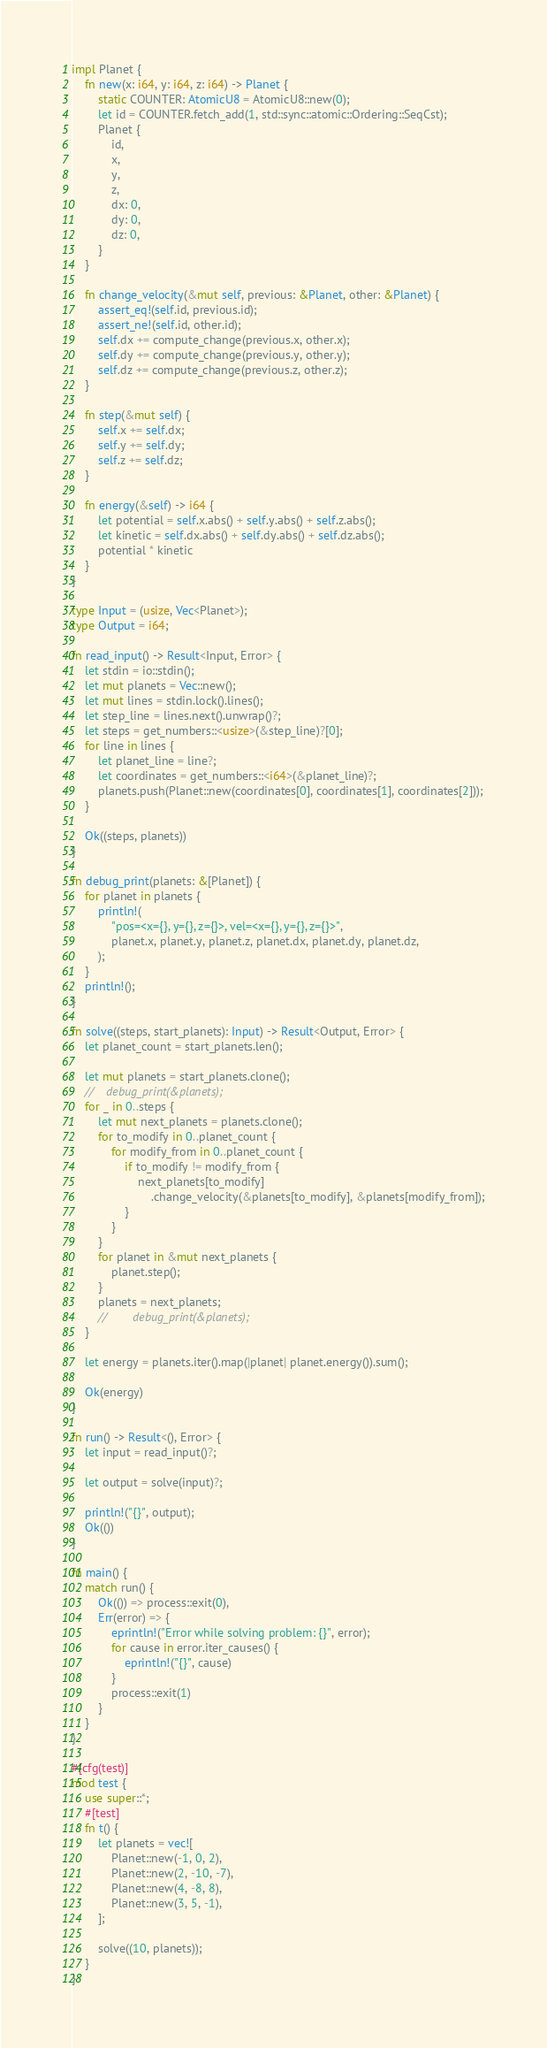Convert code to text. <code><loc_0><loc_0><loc_500><loc_500><_Rust_>
impl Planet {
    fn new(x: i64, y: i64, z: i64) -> Planet {
        static COUNTER: AtomicU8 = AtomicU8::new(0);
        let id = COUNTER.fetch_add(1, std::sync::atomic::Ordering::SeqCst);
        Planet {
            id,
            x,
            y,
            z,
            dx: 0,
            dy: 0,
            dz: 0,
        }
    }

    fn change_velocity(&mut self, previous: &Planet, other: &Planet) {
        assert_eq!(self.id, previous.id);
        assert_ne!(self.id, other.id);
        self.dx += compute_change(previous.x, other.x);
        self.dy += compute_change(previous.y, other.y);
        self.dz += compute_change(previous.z, other.z);
    }

    fn step(&mut self) {
        self.x += self.dx;
        self.y += self.dy;
        self.z += self.dz;
    }

    fn energy(&self) -> i64 {
        let potential = self.x.abs() + self.y.abs() + self.z.abs();
        let kinetic = self.dx.abs() + self.dy.abs() + self.dz.abs();
        potential * kinetic
    }
}

type Input = (usize, Vec<Planet>);
type Output = i64;

fn read_input() -> Result<Input, Error> {
    let stdin = io::stdin();
    let mut planets = Vec::new();
    let mut lines = stdin.lock().lines();
    let step_line = lines.next().unwrap()?;
    let steps = get_numbers::<usize>(&step_line)?[0];
    for line in lines {
        let planet_line = line?;
        let coordinates = get_numbers::<i64>(&planet_line)?;
        planets.push(Planet::new(coordinates[0], coordinates[1], coordinates[2]));
    }

    Ok((steps, planets))
}

fn debug_print(planets: &[Planet]) {
    for planet in planets {
        println!(
            "pos=<x={}, y={}, z={}>, vel=<x={}, y={}, z={}>",
            planet.x, planet.y, planet.z, planet.dx, planet.dy, planet.dz,
        );
    }
    println!();
}

fn solve((steps, start_planets): Input) -> Result<Output, Error> {
    let planet_count = start_planets.len();

    let mut planets = start_planets.clone();
    //    debug_print(&planets);
    for _ in 0..steps {
        let mut next_planets = planets.clone();
        for to_modify in 0..planet_count {
            for modify_from in 0..planet_count {
                if to_modify != modify_from {
                    next_planets[to_modify]
                        .change_velocity(&planets[to_modify], &planets[modify_from]);
                }
            }
        }
        for planet in &mut next_planets {
            planet.step();
        }
        planets = next_planets;
        //        debug_print(&planets);
    }

    let energy = planets.iter().map(|planet| planet.energy()).sum();

    Ok(energy)
}

fn run() -> Result<(), Error> {
    let input = read_input()?;

    let output = solve(input)?;

    println!("{}", output);
    Ok(())
}

fn main() {
    match run() {
        Ok(()) => process::exit(0),
        Err(error) => {
            eprintln!("Error while solving problem: {}", error);
            for cause in error.iter_causes() {
                eprintln!("{}", cause)
            }
            process::exit(1)
        }
    }
}

#[cfg(test)]
mod test {
    use super::*;
    #[test]
    fn t() {
        let planets = vec![
            Planet::new(-1, 0, 2),
            Planet::new(2, -10, -7),
            Planet::new(4, -8, 8),
            Planet::new(3, 5, -1),
        ];

        solve((10, planets));
    }
}
</code> 